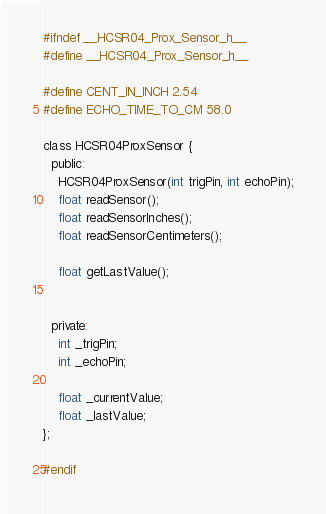<code> <loc_0><loc_0><loc_500><loc_500><_C_>#ifndef __HCSR04_Prox_Sensor_h__
#define __HCSR04_Prox_Sensor_h__

#define CENT_IN_INCH 2.54
#define ECHO_TIME_TO_CM 58.0

class HCSR04ProxSensor {
  public:
    HCSR04ProxSensor(int trigPin, int echoPin);
    float readSensor();
    float readSensorInches();
    float readSensorCentimeters();

    float getLastValue();


  private:
    int _trigPin;
    int _echoPin;

    float _currentValue;
    float _lastValue;
};

#endif

</code> 